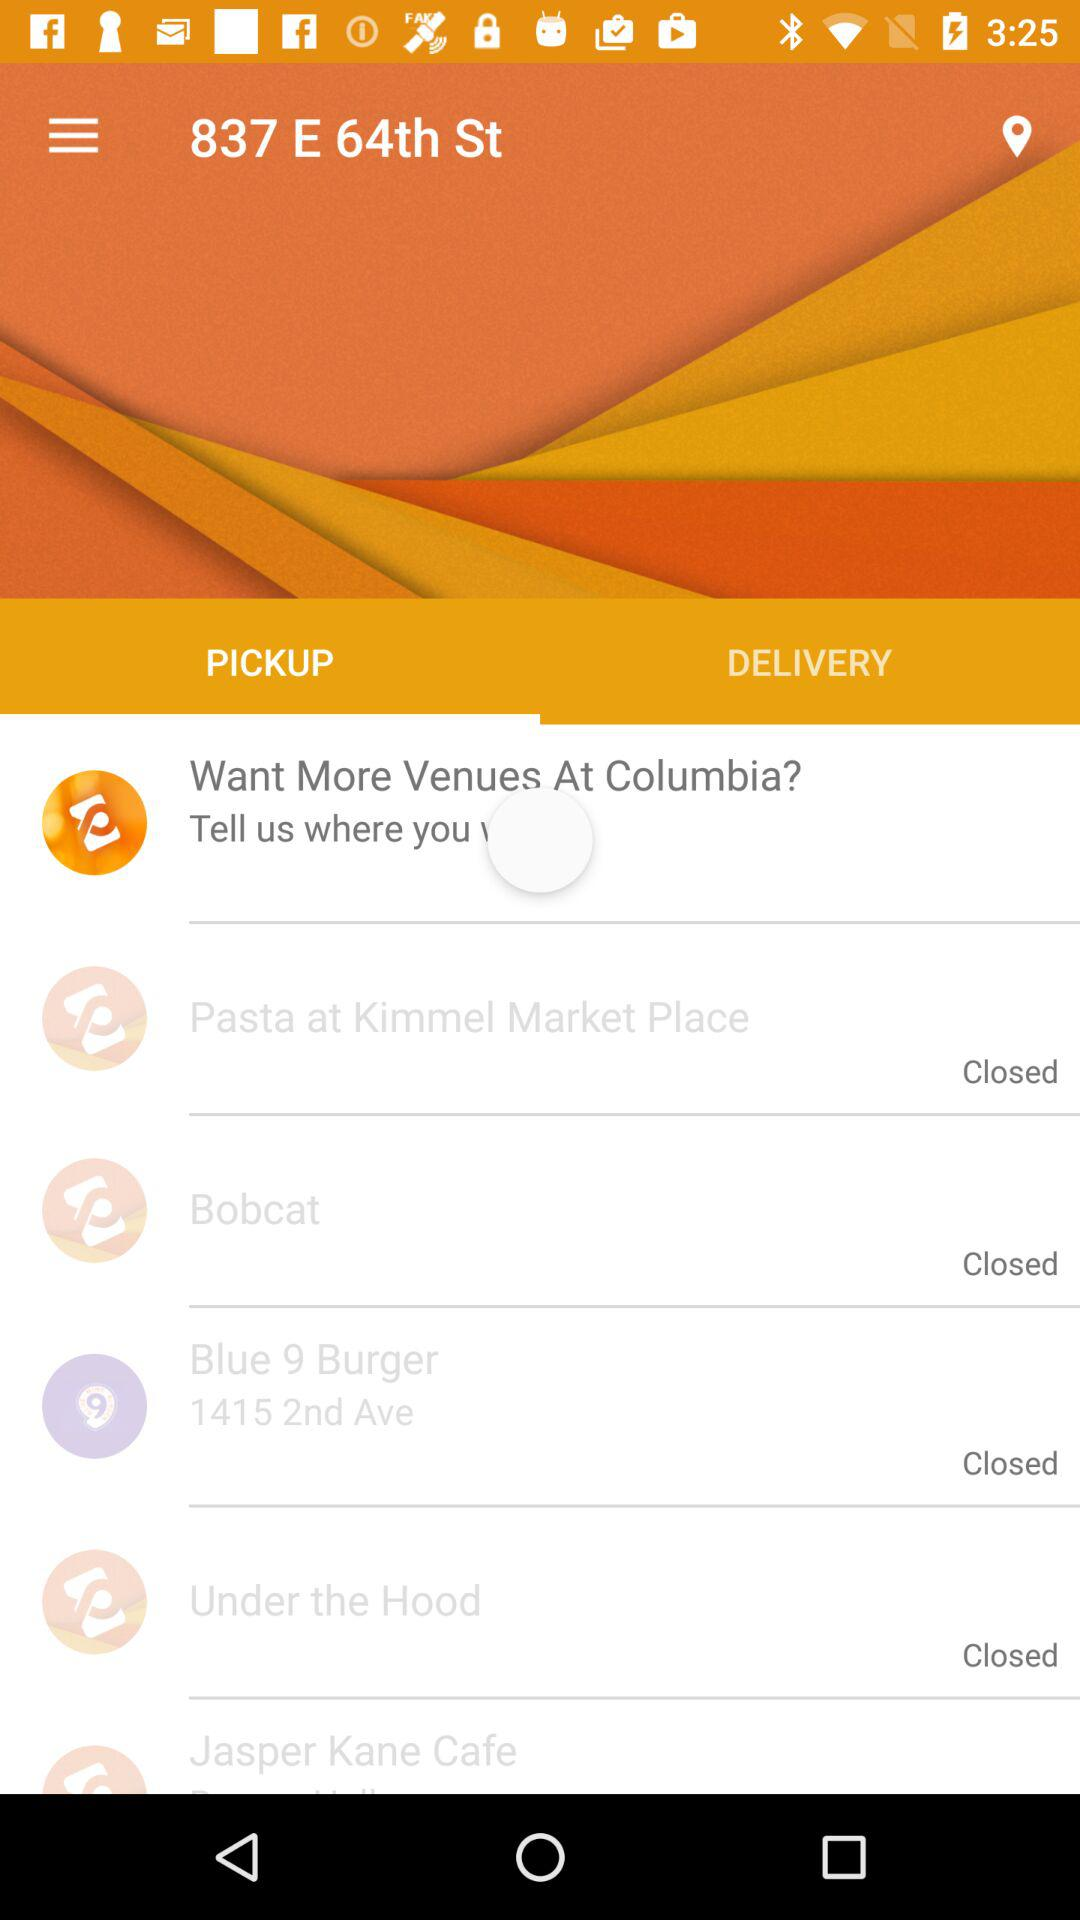Which places are closed? The closed places are "Pasta at Kimmel Market Place", "Bobcat", "Blue 9 Burger" and "Under the Hood". 